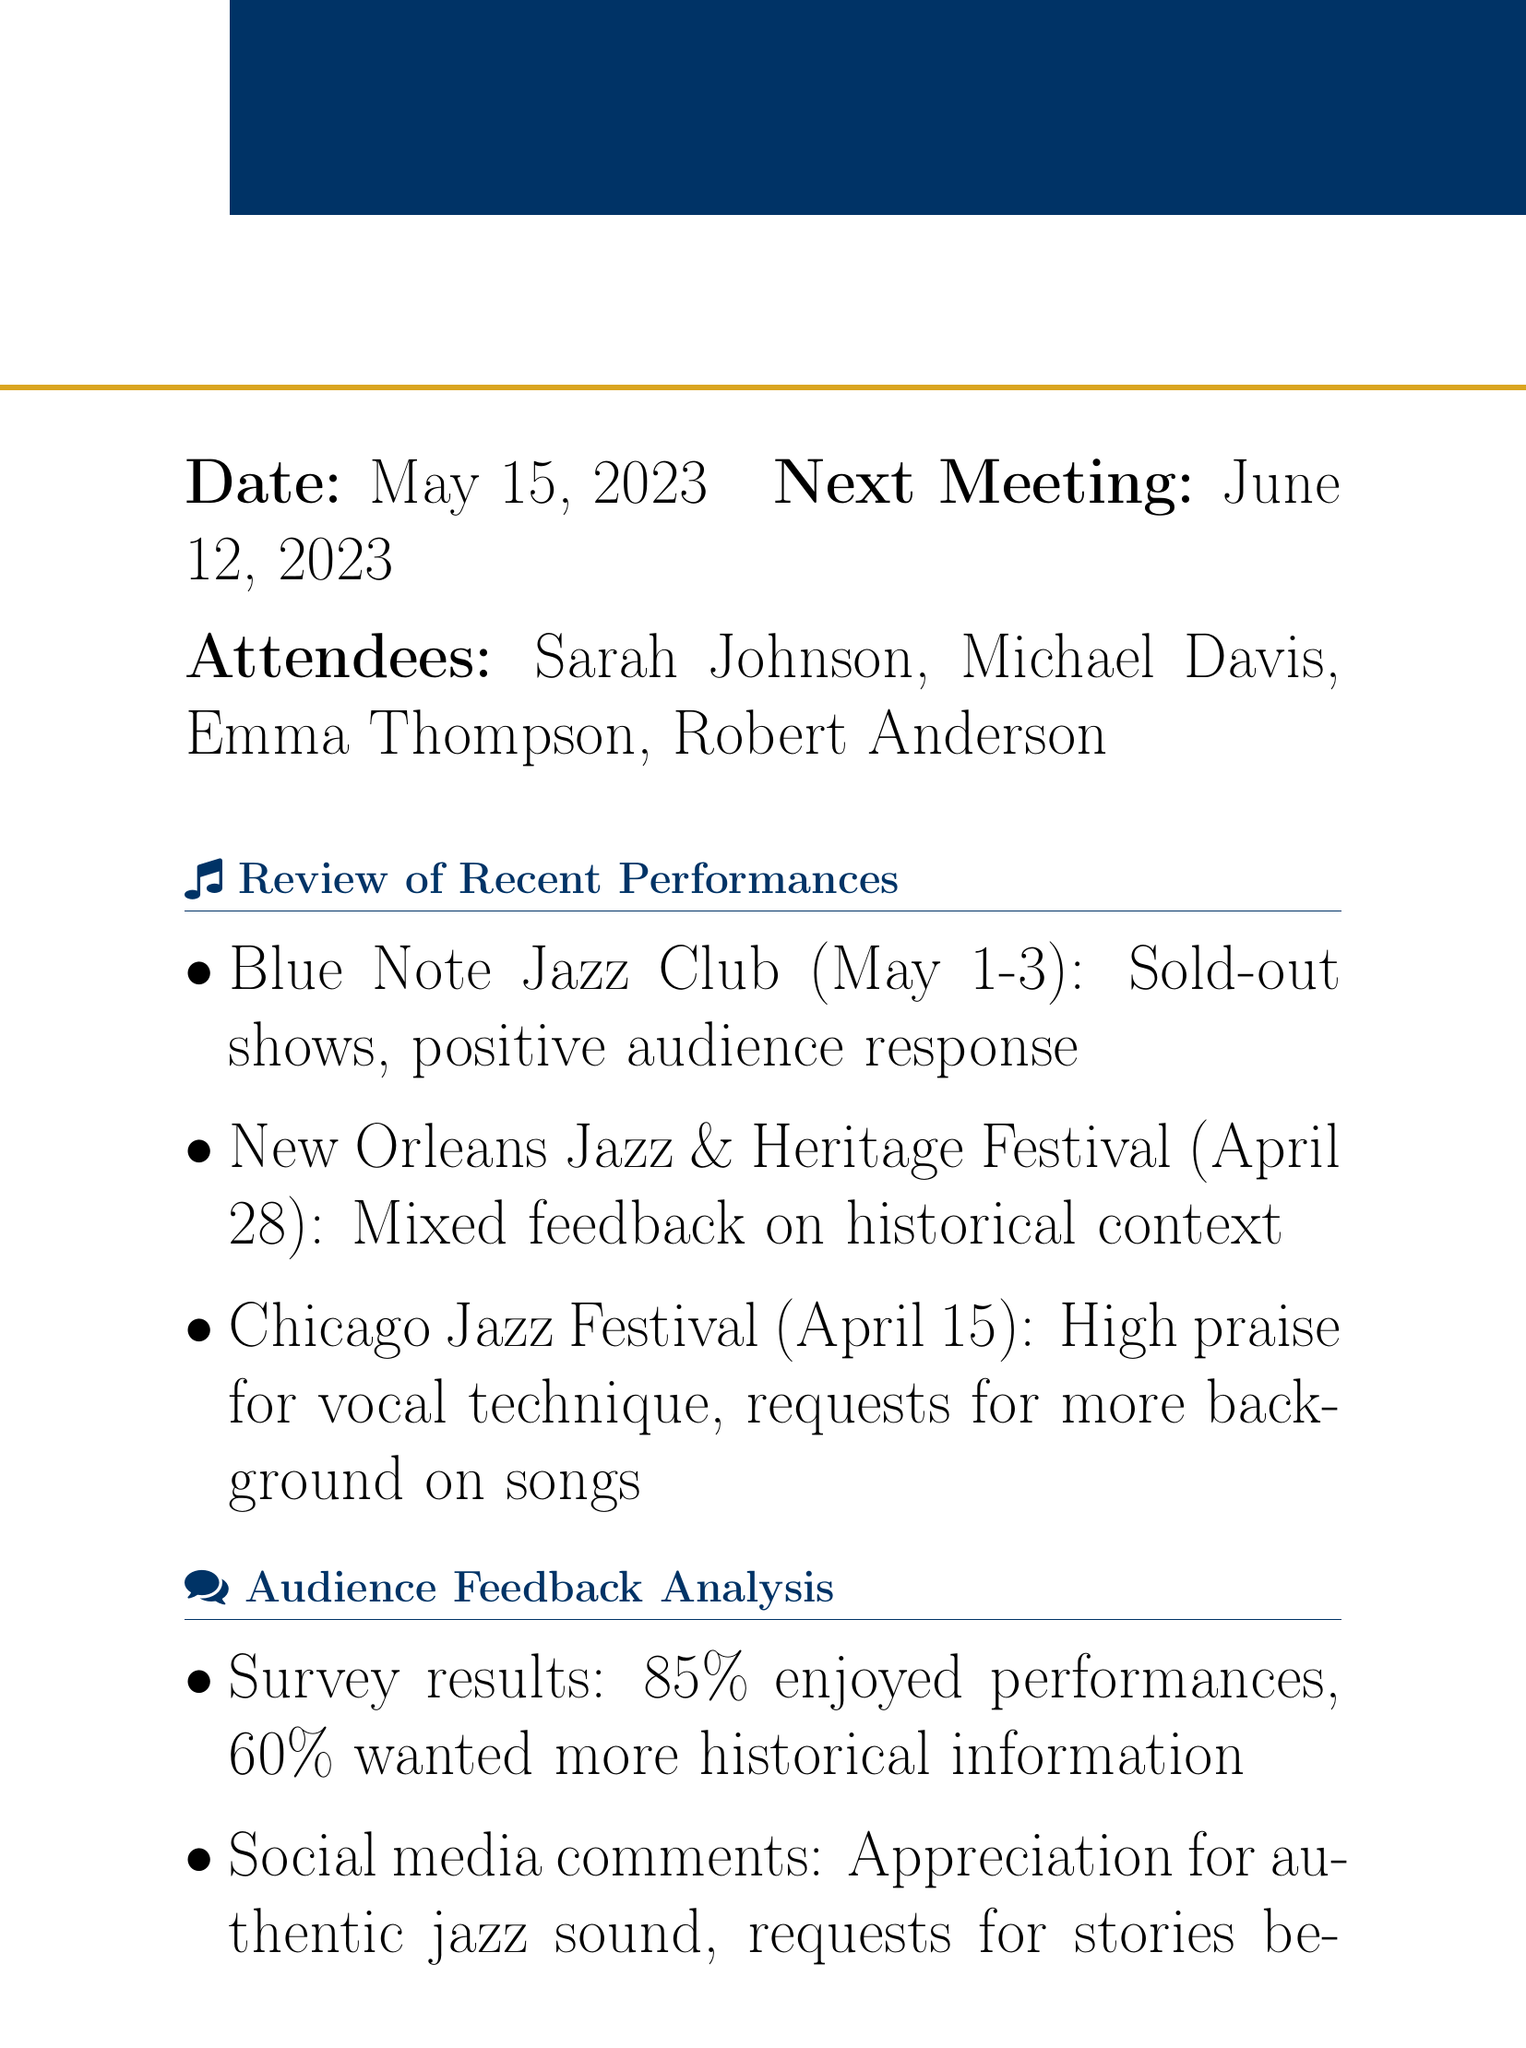what was the date of the meeting? The date of the meeting is mentioned at the beginning of the document.
Answer: May 15, 2023 who compiled the list of essential jazz history resources for the band? The action item specifies that Emma is responsible for compiling the list.
Answer: Emma Thompson what percentage of audience enjoyed the performances based on the survey results? The survey results section explicitly states the percentage of audience satisfaction.
Answer: 85% what is the focus of the action items related to improving song introductions? The action items aim to enhance the historical context in song introductions as mentioned in the agenda.
Answer: Preparing introductions which festival received mixed feedback on historical context? The document specifies one festival that had mixed feedback regarding historical context.
Answer: New Orleans Jazz & Heritage Festival how many attendees were present at the meeting? The attendees list provides the names of every individual present.
Answer: Four what is one influential jazz figure mentioned for incorporation in introductions? The document lists influential figures under improving historical context.
Answer: Louis Armstrong who is responsible for adjusting the set list? The action items indicate that Michael is in charge of this task.
Answer: Michael Davis what is the next meeting date? The next meeting date is provided at the end of the document.
Answer: June 12, 2023 